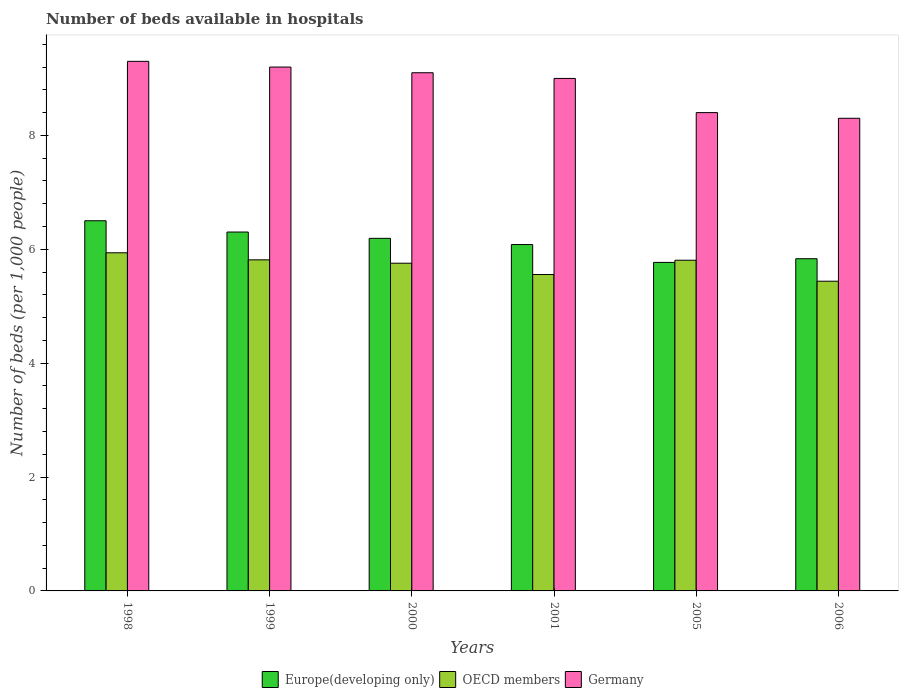How many different coloured bars are there?
Keep it short and to the point. 3. How many groups of bars are there?
Your answer should be very brief. 6. How many bars are there on the 2nd tick from the left?
Provide a short and direct response. 3. What is the number of beds in the hospiatls of in OECD members in 1999?
Make the answer very short. 5.81. Across all years, what is the maximum number of beds in the hospiatls of in Europe(developing only)?
Your answer should be compact. 6.5. Across all years, what is the minimum number of beds in the hospiatls of in OECD members?
Your response must be concise. 5.44. In which year was the number of beds in the hospiatls of in Germany minimum?
Provide a short and direct response. 2006. What is the total number of beds in the hospiatls of in Germany in the graph?
Your answer should be compact. 53.3. What is the difference between the number of beds in the hospiatls of in OECD members in 2001 and that in 2006?
Provide a short and direct response. 0.12. What is the difference between the number of beds in the hospiatls of in OECD members in 2005 and the number of beds in the hospiatls of in Germany in 2001?
Provide a succinct answer. -3.19. What is the average number of beds in the hospiatls of in OECD members per year?
Offer a very short reply. 5.72. In the year 2006, what is the difference between the number of beds in the hospiatls of in OECD members and number of beds in the hospiatls of in Europe(developing only)?
Offer a very short reply. -0.4. In how many years, is the number of beds in the hospiatls of in OECD members greater than 8.8?
Your answer should be compact. 0. What is the ratio of the number of beds in the hospiatls of in Germany in 1999 to that in 2001?
Your answer should be very brief. 1.02. Is the difference between the number of beds in the hospiatls of in OECD members in 1998 and 2001 greater than the difference between the number of beds in the hospiatls of in Europe(developing only) in 1998 and 2001?
Make the answer very short. No. What is the difference between the highest and the second highest number of beds in the hospiatls of in OECD members?
Offer a terse response. 0.12. What is the difference between the highest and the lowest number of beds in the hospiatls of in OECD members?
Ensure brevity in your answer.  0.5. Is the sum of the number of beds in the hospiatls of in OECD members in 2000 and 2006 greater than the maximum number of beds in the hospiatls of in Germany across all years?
Make the answer very short. Yes. What does the 1st bar from the left in 1998 represents?
Make the answer very short. Europe(developing only). What does the 2nd bar from the right in 2005 represents?
Your answer should be compact. OECD members. Are all the bars in the graph horizontal?
Offer a terse response. No. What is the difference between two consecutive major ticks on the Y-axis?
Your answer should be very brief. 2. Are the values on the major ticks of Y-axis written in scientific E-notation?
Your answer should be very brief. No. Where does the legend appear in the graph?
Give a very brief answer. Bottom center. What is the title of the graph?
Make the answer very short. Number of beds available in hospitals. What is the label or title of the Y-axis?
Ensure brevity in your answer.  Number of beds (per 1,0 people). What is the Number of beds (per 1,000 people) of Europe(developing only) in 1998?
Provide a short and direct response. 6.5. What is the Number of beds (per 1,000 people) of OECD members in 1998?
Give a very brief answer. 5.94. What is the Number of beds (per 1,000 people) in Germany in 1998?
Ensure brevity in your answer.  9.3. What is the Number of beds (per 1,000 people) in Europe(developing only) in 1999?
Provide a short and direct response. 6.3. What is the Number of beds (per 1,000 people) in OECD members in 1999?
Provide a short and direct response. 5.81. What is the Number of beds (per 1,000 people) of Germany in 1999?
Your answer should be very brief. 9.2. What is the Number of beds (per 1,000 people) of Europe(developing only) in 2000?
Your answer should be very brief. 6.19. What is the Number of beds (per 1,000 people) of OECD members in 2000?
Provide a short and direct response. 5.76. What is the Number of beds (per 1,000 people) in Germany in 2000?
Your response must be concise. 9.1. What is the Number of beds (per 1,000 people) of Europe(developing only) in 2001?
Offer a very short reply. 6.08. What is the Number of beds (per 1,000 people) of OECD members in 2001?
Provide a short and direct response. 5.56. What is the Number of beds (per 1,000 people) of Germany in 2001?
Provide a succinct answer. 9. What is the Number of beds (per 1,000 people) in Europe(developing only) in 2005?
Your answer should be compact. 5.77. What is the Number of beds (per 1,000 people) of OECD members in 2005?
Ensure brevity in your answer.  5.81. What is the Number of beds (per 1,000 people) in Europe(developing only) in 2006?
Make the answer very short. 5.83. What is the Number of beds (per 1,000 people) in OECD members in 2006?
Your response must be concise. 5.44. Across all years, what is the maximum Number of beds (per 1,000 people) of Europe(developing only)?
Provide a succinct answer. 6.5. Across all years, what is the maximum Number of beds (per 1,000 people) in OECD members?
Offer a very short reply. 5.94. Across all years, what is the maximum Number of beds (per 1,000 people) of Germany?
Keep it short and to the point. 9.3. Across all years, what is the minimum Number of beds (per 1,000 people) in Europe(developing only)?
Ensure brevity in your answer.  5.77. Across all years, what is the minimum Number of beds (per 1,000 people) in OECD members?
Offer a terse response. 5.44. What is the total Number of beds (per 1,000 people) of Europe(developing only) in the graph?
Your answer should be very brief. 36.68. What is the total Number of beds (per 1,000 people) in OECD members in the graph?
Offer a terse response. 34.31. What is the total Number of beds (per 1,000 people) in Germany in the graph?
Keep it short and to the point. 53.3. What is the difference between the Number of beds (per 1,000 people) of Europe(developing only) in 1998 and that in 1999?
Offer a very short reply. 0.2. What is the difference between the Number of beds (per 1,000 people) of OECD members in 1998 and that in 1999?
Keep it short and to the point. 0.12. What is the difference between the Number of beds (per 1,000 people) of Europe(developing only) in 1998 and that in 2000?
Keep it short and to the point. 0.31. What is the difference between the Number of beds (per 1,000 people) of OECD members in 1998 and that in 2000?
Make the answer very short. 0.18. What is the difference between the Number of beds (per 1,000 people) in Europe(developing only) in 1998 and that in 2001?
Keep it short and to the point. 0.42. What is the difference between the Number of beds (per 1,000 people) in OECD members in 1998 and that in 2001?
Keep it short and to the point. 0.38. What is the difference between the Number of beds (per 1,000 people) in Europe(developing only) in 1998 and that in 2005?
Your response must be concise. 0.73. What is the difference between the Number of beds (per 1,000 people) in OECD members in 1998 and that in 2005?
Your answer should be compact. 0.13. What is the difference between the Number of beds (per 1,000 people) of Europe(developing only) in 1998 and that in 2006?
Your answer should be compact. 0.67. What is the difference between the Number of beds (per 1,000 people) in OECD members in 1998 and that in 2006?
Your answer should be compact. 0.5. What is the difference between the Number of beds (per 1,000 people) of Germany in 1998 and that in 2006?
Provide a short and direct response. 1. What is the difference between the Number of beds (per 1,000 people) of Europe(developing only) in 1999 and that in 2000?
Provide a succinct answer. 0.11. What is the difference between the Number of beds (per 1,000 people) of OECD members in 1999 and that in 2000?
Provide a short and direct response. 0.06. What is the difference between the Number of beds (per 1,000 people) of Germany in 1999 and that in 2000?
Provide a succinct answer. 0.1. What is the difference between the Number of beds (per 1,000 people) in Europe(developing only) in 1999 and that in 2001?
Ensure brevity in your answer.  0.22. What is the difference between the Number of beds (per 1,000 people) of OECD members in 1999 and that in 2001?
Make the answer very short. 0.26. What is the difference between the Number of beds (per 1,000 people) in Germany in 1999 and that in 2001?
Ensure brevity in your answer.  0.2. What is the difference between the Number of beds (per 1,000 people) of Europe(developing only) in 1999 and that in 2005?
Ensure brevity in your answer.  0.53. What is the difference between the Number of beds (per 1,000 people) of OECD members in 1999 and that in 2005?
Ensure brevity in your answer.  0.01. What is the difference between the Number of beds (per 1,000 people) in Europe(developing only) in 1999 and that in 2006?
Keep it short and to the point. 0.47. What is the difference between the Number of beds (per 1,000 people) of OECD members in 1999 and that in 2006?
Provide a short and direct response. 0.38. What is the difference between the Number of beds (per 1,000 people) of Germany in 1999 and that in 2006?
Your answer should be very brief. 0.9. What is the difference between the Number of beds (per 1,000 people) in Europe(developing only) in 2000 and that in 2001?
Your answer should be compact. 0.11. What is the difference between the Number of beds (per 1,000 people) in OECD members in 2000 and that in 2001?
Provide a succinct answer. 0.2. What is the difference between the Number of beds (per 1,000 people) in Germany in 2000 and that in 2001?
Make the answer very short. 0.1. What is the difference between the Number of beds (per 1,000 people) of Europe(developing only) in 2000 and that in 2005?
Keep it short and to the point. 0.42. What is the difference between the Number of beds (per 1,000 people) in OECD members in 2000 and that in 2005?
Make the answer very short. -0.05. What is the difference between the Number of beds (per 1,000 people) of Europe(developing only) in 2000 and that in 2006?
Offer a very short reply. 0.36. What is the difference between the Number of beds (per 1,000 people) of OECD members in 2000 and that in 2006?
Provide a succinct answer. 0.32. What is the difference between the Number of beds (per 1,000 people) of Germany in 2000 and that in 2006?
Ensure brevity in your answer.  0.8. What is the difference between the Number of beds (per 1,000 people) in Europe(developing only) in 2001 and that in 2005?
Offer a very short reply. 0.31. What is the difference between the Number of beds (per 1,000 people) in OECD members in 2001 and that in 2005?
Your answer should be very brief. -0.25. What is the difference between the Number of beds (per 1,000 people) in Europe(developing only) in 2001 and that in 2006?
Your response must be concise. 0.25. What is the difference between the Number of beds (per 1,000 people) in OECD members in 2001 and that in 2006?
Provide a succinct answer. 0.12. What is the difference between the Number of beds (per 1,000 people) in Germany in 2001 and that in 2006?
Make the answer very short. 0.7. What is the difference between the Number of beds (per 1,000 people) in Europe(developing only) in 2005 and that in 2006?
Provide a short and direct response. -0.06. What is the difference between the Number of beds (per 1,000 people) of OECD members in 2005 and that in 2006?
Give a very brief answer. 0.37. What is the difference between the Number of beds (per 1,000 people) in Europe(developing only) in 1998 and the Number of beds (per 1,000 people) in OECD members in 1999?
Keep it short and to the point. 0.69. What is the difference between the Number of beds (per 1,000 people) of Europe(developing only) in 1998 and the Number of beds (per 1,000 people) of Germany in 1999?
Offer a terse response. -2.7. What is the difference between the Number of beds (per 1,000 people) in OECD members in 1998 and the Number of beds (per 1,000 people) in Germany in 1999?
Ensure brevity in your answer.  -3.26. What is the difference between the Number of beds (per 1,000 people) of Europe(developing only) in 1998 and the Number of beds (per 1,000 people) of OECD members in 2000?
Provide a short and direct response. 0.75. What is the difference between the Number of beds (per 1,000 people) of Europe(developing only) in 1998 and the Number of beds (per 1,000 people) of Germany in 2000?
Your answer should be compact. -2.6. What is the difference between the Number of beds (per 1,000 people) in OECD members in 1998 and the Number of beds (per 1,000 people) in Germany in 2000?
Make the answer very short. -3.16. What is the difference between the Number of beds (per 1,000 people) in Europe(developing only) in 1998 and the Number of beds (per 1,000 people) in Germany in 2001?
Your answer should be compact. -2.5. What is the difference between the Number of beds (per 1,000 people) in OECD members in 1998 and the Number of beds (per 1,000 people) in Germany in 2001?
Your answer should be compact. -3.06. What is the difference between the Number of beds (per 1,000 people) of Europe(developing only) in 1998 and the Number of beds (per 1,000 people) of OECD members in 2005?
Your answer should be very brief. 0.69. What is the difference between the Number of beds (per 1,000 people) of Europe(developing only) in 1998 and the Number of beds (per 1,000 people) of Germany in 2005?
Provide a short and direct response. -1.9. What is the difference between the Number of beds (per 1,000 people) of OECD members in 1998 and the Number of beds (per 1,000 people) of Germany in 2005?
Your answer should be compact. -2.46. What is the difference between the Number of beds (per 1,000 people) in Europe(developing only) in 1998 and the Number of beds (per 1,000 people) in OECD members in 2006?
Offer a very short reply. 1.06. What is the difference between the Number of beds (per 1,000 people) of Europe(developing only) in 1998 and the Number of beds (per 1,000 people) of Germany in 2006?
Give a very brief answer. -1.8. What is the difference between the Number of beds (per 1,000 people) in OECD members in 1998 and the Number of beds (per 1,000 people) in Germany in 2006?
Keep it short and to the point. -2.36. What is the difference between the Number of beds (per 1,000 people) of Europe(developing only) in 1999 and the Number of beds (per 1,000 people) of OECD members in 2000?
Give a very brief answer. 0.55. What is the difference between the Number of beds (per 1,000 people) in Europe(developing only) in 1999 and the Number of beds (per 1,000 people) in Germany in 2000?
Provide a short and direct response. -2.8. What is the difference between the Number of beds (per 1,000 people) in OECD members in 1999 and the Number of beds (per 1,000 people) in Germany in 2000?
Provide a succinct answer. -3.29. What is the difference between the Number of beds (per 1,000 people) in Europe(developing only) in 1999 and the Number of beds (per 1,000 people) in OECD members in 2001?
Give a very brief answer. 0.75. What is the difference between the Number of beds (per 1,000 people) of Europe(developing only) in 1999 and the Number of beds (per 1,000 people) of Germany in 2001?
Your response must be concise. -2.7. What is the difference between the Number of beds (per 1,000 people) of OECD members in 1999 and the Number of beds (per 1,000 people) of Germany in 2001?
Provide a short and direct response. -3.19. What is the difference between the Number of beds (per 1,000 people) of Europe(developing only) in 1999 and the Number of beds (per 1,000 people) of OECD members in 2005?
Offer a terse response. 0.49. What is the difference between the Number of beds (per 1,000 people) in Europe(developing only) in 1999 and the Number of beds (per 1,000 people) in Germany in 2005?
Your response must be concise. -2.1. What is the difference between the Number of beds (per 1,000 people) of OECD members in 1999 and the Number of beds (per 1,000 people) of Germany in 2005?
Provide a short and direct response. -2.59. What is the difference between the Number of beds (per 1,000 people) of Europe(developing only) in 1999 and the Number of beds (per 1,000 people) of OECD members in 2006?
Ensure brevity in your answer.  0.86. What is the difference between the Number of beds (per 1,000 people) of Europe(developing only) in 1999 and the Number of beds (per 1,000 people) of Germany in 2006?
Offer a very short reply. -2. What is the difference between the Number of beds (per 1,000 people) in OECD members in 1999 and the Number of beds (per 1,000 people) in Germany in 2006?
Give a very brief answer. -2.49. What is the difference between the Number of beds (per 1,000 people) of Europe(developing only) in 2000 and the Number of beds (per 1,000 people) of OECD members in 2001?
Give a very brief answer. 0.64. What is the difference between the Number of beds (per 1,000 people) in Europe(developing only) in 2000 and the Number of beds (per 1,000 people) in Germany in 2001?
Provide a short and direct response. -2.81. What is the difference between the Number of beds (per 1,000 people) in OECD members in 2000 and the Number of beds (per 1,000 people) in Germany in 2001?
Your answer should be very brief. -3.24. What is the difference between the Number of beds (per 1,000 people) of Europe(developing only) in 2000 and the Number of beds (per 1,000 people) of OECD members in 2005?
Offer a very short reply. 0.38. What is the difference between the Number of beds (per 1,000 people) of Europe(developing only) in 2000 and the Number of beds (per 1,000 people) of Germany in 2005?
Your answer should be very brief. -2.21. What is the difference between the Number of beds (per 1,000 people) of OECD members in 2000 and the Number of beds (per 1,000 people) of Germany in 2005?
Provide a succinct answer. -2.64. What is the difference between the Number of beds (per 1,000 people) in Europe(developing only) in 2000 and the Number of beds (per 1,000 people) in OECD members in 2006?
Your answer should be very brief. 0.75. What is the difference between the Number of beds (per 1,000 people) in Europe(developing only) in 2000 and the Number of beds (per 1,000 people) in Germany in 2006?
Keep it short and to the point. -2.11. What is the difference between the Number of beds (per 1,000 people) of OECD members in 2000 and the Number of beds (per 1,000 people) of Germany in 2006?
Your answer should be very brief. -2.54. What is the difference between the Number of beds (per 1,000 people) in Europe(developing only) in 2001 and the Number of beds (per 1,000 people) in OECD members in 2005?
Make the answer very short. 0.28. What is the difference between the Number of beds (per 1,000 people) of Europe(developing only) in 2001 and the Number of beds (per 1,000 people) of Germany in 2005?
Your response must be concise. -2.32. What is the difference between the Number of beds (per 1,000 people) of OECD members in 2001 and the Number of beds (per 1,000 people) of Germany in 2005?
Give a very brief answer. -2.84. What is the difference between the Number of beds (per 1,000 people) of Europe(developing only) in 2001 and the Number of beds (per 1,000 people) of OECD members in 2006?
Provide a succinct answer. 0.64. What is the difference between the Number of beds (per 1,000 people) of Europe(developing only) in 2001 and the Number of beds (per 1,000 people) of Germany in 2006?
Offer a terse response. -2.22. What is the difference between the Number of beds (per 1,000 people) of OECD members in 2001 and the Number of beds (per 1,000 people) of Germany in 2006?
Give a very brief answer. -2.74. What is the difference between the Number of beds (per 1,000 people) in Europe(developing only) in 2005 and the Number of beds (per 1,000 people) in OECD members in 2006?
Keep it short and to the point. 0.33. What is the difference between the Number of beds (per 1,000 people) of Europe(developing only) in 2005 and the Number of beds (per 1,000 people) of Germany in 2006?
Offer a terse response. -2.53. What is the difference between the Number of beds (per 1,000 people) of OECD members in 2005 and the Number of beds (per 1,000 people) of Germany in 2006?
Your answer should be very brief. -2.49. What is the average Number of beds (per 1,000 people) of Europe(developing only) per year?
Your response must be concise. 6.11. What is the average Number of beds (per 1,000 people) of OECD members per year?
Give a very brief answer. 5.72. What is the average Number of beds (per 1,000 people) of Germany per year?
Your response must be concise. 8.88. In the year 1998, what is the difference between the Number of beds (per 1,000 people) in Europe(developing only) and Number of beds (per 1,000 people) in OECD members?
Ensure brevity in your answer.  0.56. In the year 1998, what is the difference between the Number of beds (per 1,000 people) in Europe(developing only) and Number of beds (per 1,000 people) in Germany?
Make the answer very short. -2.8. In the year 1998, what is the difference between the Number of beds (per 1,000 people) in OECD members and Number of beds (per 1,000 people) in Germany?
Provide a succinct answer. -3.36. In the year 1999, what is the difference between the Number of beds (per 1,000 people) in Europe(developing only) and Number of beds (per 1,000 people) in OECD members?
Ensure brevity in your answer.  0.49. In the year 1999, what is the difference between the Number of beds (per 1,000 people) of Europe(developing only) and Number of beds (per 1,000 people) of Germany?
Ensure brevity in your answer.  -2.9. In the year 1999, what is the difference between the Number of beds (per 1,000 people) of OECD members and Number of beds (per 1,000 people) of Germany?
Your answer should be compact. -3.39. In the year 2000, what is the difference between the Number of beds (per 1,000 people) of Europe(developing only) and Number of beds (per 1,000 people) of OECD members?
Give a very brief answer. 0.44. In the year 2000, what is the difference between the Number of beds (per 1,000 people) in Europe(developing only) and Number of beds (per 1,000 people) in Germany?
Provide a short and direct response. -2.91. In the year 2000, what is the difference between the Number of beds (per 1,000 people) in OECD members and Number of beds (per 1,000 people) in Germany?
Your response must be concise. -3.34. In the year 2001, what is the difference between the Number of beds (per 1,000 people) of Europe(developing only) and Number of beds (per 1,000 people) of OECD members?
Your answer should be compact. 0.53. In the year 2001, what is the difference between the Number of beds (per 1,000 people) in Europe(developing only) and Number of beds (per 1,000 people) in Germany?
Your answer should be very brief. -2.92. In the year 2001, what is the difference between the Number of beds (per 1,000 people) in OECD members and Number of beds (per 1,000 people) in Germany?
Offer a very short reply. -3.44. In the year 2005, what is the difference between the Number of beds (per 1,000 people) in Europe(developing only) and Number of beds (per 1,000 people) in OECD members?
Make the answer very short. -0.04. In the year 2005, what is the difference between the Number of beds (per 1,000 people) in Europe(developing only) and Number of beds (per 1,000 people) in Germany?
Provide a short and direct response. -2.63. In the year 2005, what is the difference between the Number of beds (per 1,000 people) of OECD members and Number of beds (per 1,000 people) of Germany?
Offer a terse response. -2.59. In the year 2006, what is the difference between the Number of beds (per 1,000 people) in Europe(developing only) and Number of beds (per 1,000 people) in OECD members?
Ensure brevity in your answer.  0.4. In the year 2006, what is the difference between the Number of beds (per 1,000 people) in Europe(developing only) and Number of beds (per 1,000 people) in Germany?
Keep it short and to the point. -2.47. In the year 2006, what is the difference between the Number of beds (per 1,000 people) in OECD members and Number of beds (per 1,000 people) in Germany?
Provide a succinct answer. -2.86. What is the ratio of the Number of beds (per 1,000 people) of Europe(developing only) in 1998 to that in 1999?
Keep it short and to the point. 1.03. What is the ratio of the Number of beds (per 1,000 people) of OECD members in 1998 to that in 1999?
Ensure brevity in your answer.  1.02. What is the ratio of the Number of beds (per 1,000 people) in Germany in 1998 to that in 1999?
Your response must be concise. 1.01. What is the ratio of the Number of beds (per 1,000 people) of Europe(developing only) in 1998 to that in 2000?
Provide a short and direct response. 1.05. What is the ratio of the Number of beds (per 1,000 people) of OECD members in 1998 to that in 2000?
Make the answer very short. 1.03. What is the ratio of the Number of beds (per 1,000 people) in Germany in 1998 to that in 2000?
Your answer should be very brief. 1.02. What is the ratio of the Number of beds (per 1,000 people) in Europe(developing only) in 1998 to that in 2001?
Provide a short and direct response. 1.07. What is the ratio of the Number of beds (per 1,000 people) in OECD members in 1998 to that in 2001?
Your response must be concise. 1.07. What is the ratio of the Number of beds (per 1,000 people) in Europe(developing only) in 1998 to that in 2005?
Provide a succinct answer. 1.13. What is the ratio of the Number of beds (per 1,000 people) in OECD members in 1998 to that in 2005?
Your answer should be compact. 1.02. What is the ratio of the Number of beds (per 1,000 people) in Germany in 1998 to that in 2005?
Ensure brevity in your answer.  1.11. What is the ratio of the Number of beds (per 1,000 people) in Europe(developing only) in 1998 to that in 2006?
Provide a succinct answer. 1.11. What is the ratio of the Number of beds (per 1,000 people) in OECD members in 1998 to that in 2006?
Offer a very short reply. 1.09. What is the ratio of the Number of beds (per 1,000 people) in Germany in 1998 to that in 2006?
Provide a short and direct response. 1.12. What is the ratio of the Number of beds (per 1,000 people) of Europe(developing only) in 1999 to that in 2000?
Your answer should be very brief. 1.02. What is the ratio of the Number of beds (per 1,000 people) in OECD members in 1999 to that in 2000?
Your response must be concise. 1.01. What is the ratio of the Number of beds (per 1,000 people) in Germany in 1999 to that in 2000?
Ensure brevity in your answer.  1.01. What is the ratio of the Number of beds (per 1,000 people) in Europe(developing only) in 1999 to that in 2001?
Your answer should be compact. 1.04. What is the ratio of the Number of beds (per 1,000 people) of OECD members in 1999 to that in 2001?
Offer a very short reply. 1.05. What is the ratio of the Number of beds (per 1,000 people) in Germany in 1999 to that in 2001?
Make the answer very short. 1.02. What is the ratio of the Number of beds (per 1,000 people) in Europe(developing only) in 1999 to that in 2005?
Your response must be concise. 1.09. What is the ratio of the Number of beds (per 1,000 people) in Germany in 1999 to that in 2005?
Keep it short and to the point. 1.1. What is the ratio of the Number of beds (per 1,000 people) of Europe(developing only) in 1999 to that in 2006?
Your answer should be compact. 1.08. What is the ratio of the Number of beds (per 1,000 people) of OECD members in 1999 to that in 2006?
Offer a terse response. 1.07. What is the ratio of the Number of beds (per 1,000 people) in Germany in 1999 to that in 2006?
Provide a short and direct response. 1.11. What is the ratio of the Number of beds (per 1,000 people) of OECD members in 2000 to that in 2001?
Ensure brevity in your answer.  1.04. What is the ratio of the Number of beds (per 1,000 people) of Germany in 2000 to that in 2001?
Ensure brevity in your answer.  1.01. What is the ratio of the Number of beds (per 1,000 people) of Europe(developing only) in 2000 to that in 2005?
Offer a very short reply. 1.07. What is the ratio of the Number of beds (per 1,000 people) in OECD members in 2000 to that in 2005?
Provide a short and direct response. 0.99. What is the ratio of the Number of beds (per 1,000 people) of Germany in 2000 to that in 2005?
Offer a very short reply. 1.08. What is the ratio of the Number of beds (per 1,000 people) of Europe(developing only) in 2000 to that in 2006?
Give a very brief answer. 1.06. What is the ratio of the Number of beds (per 1,000 people) in OECD members in 2000 to that in 2006?
Offer a very short reply. 1.06. What is the ratio of the Number of beds (per 1,000 people) of Germany in 2000 to that in 2006?
Offer a terse response. 1.1. What is the ratio of the Number of beds (per 1,000 people) in Europe(developing only) in 2001 to that in 2005?
Ensure brevity in your answer.  1.05. What is the ratio of the Number of beds (per 1,000 people) of OECD members in 2001 to that in 2005?
Provide a succinct answer. 0.96. What is the ratio of the Number of beds (per 1,000 people) of Germany in 2001 to that in 2005?
Make the answer very short. 1.07. What is the ratio of the Number of beds (per 1,000 people) of Europe(developing only) in 2001 to that in 2006?
Offer a terse response. 1.04. What is the ratio of the Number of beds (per 1,000 people) in OECD members in 2001 to that in 2006?
Your response must be concise. 1.02. What is the ratio of the Number of beds (per 1,000 people) of Germany in 2001 to that in 2006?
Provide a succinct answer. 1.08. What is the ratio of the Number of beds (per 1,000 people) of Europe(developing only) in 2005 to that in 2006?
Provide a short and direct response. 0.99. What is the ratio of the Number of beds (per 1,000 people) of OECD members in 2005 to that in 2006?
Your response must be concise. 1.07. What is the difference between the highest and the second highest Number of beds (per 1,000 people) in Europe(developing only)?
Your response must be concise. 0.2. What is the difference between the highest and the second highest Number of beds (per 1,000 people) of OECD members?
Provide a short and direct response. 0.12. What is the difference between the highest and the lowest Number of beds (per 1,000 people) in Europe(developing only)?
Make the answer very short. 0.73. What is the difference between the highest and the lowest Number of beds (per 1,000 people) of OECD members?
Provide a succinct answer. 0.5. 